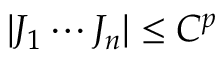<formula> <loc_0><loc_0><loc_500><loc_500>| J _ { 1 } \cdots J _ { n } | \leq C ^ { p }</formula> 